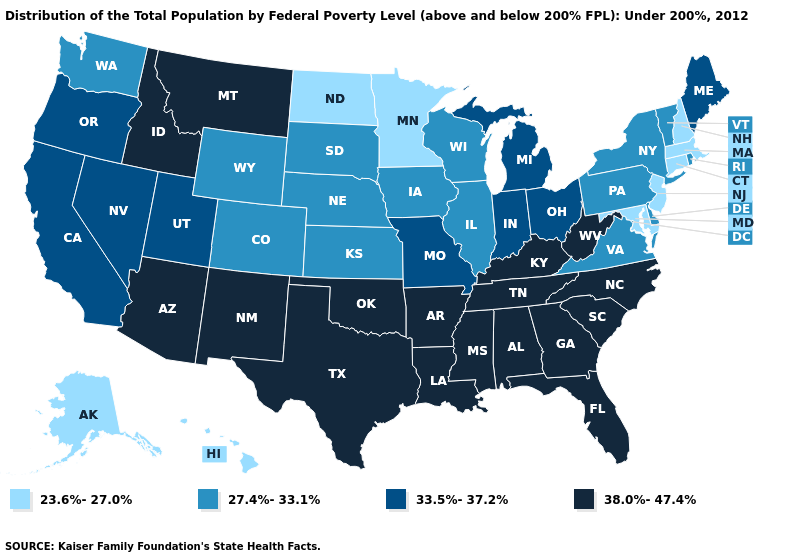Name the states that have a value in the range 33.5%-37.2%?
Write a very short answer. California, Indiana, Maine, Michigan, Missouri, Nevada, Ohio, Oregon, Utah. Does New Mexico have the highest value in the West?
Quick response, please. Yes. What is the value of Maine?
Short answer required. 33.5%-37.2%. What is the highest value in the Northeast ?
Quick response, please. 33.5%-37.2%. Name the states that have a value in the range 38.0%-47.4%?
Quick response, please. Alabama, Arizona, Arkansas, Florida, Georgia, Idaho, Kentucky, Louisiana, Mississippi, Montana, New Mexico, North Carolina, Oklahoma, South Carolina, Tennessee, Texas, West Virginia. Name the states that have a value in the range 38.0%-47.4%?
Concise answer only. Alabama, Arizona, Arkansas, Florida, Georgia, Idaho, Kentucky, Louisiana, Mississippi, Montana, New Mexico, North Carolina, Oklahoma, South Carolina, Tennessee, Texas, West Virginia. Name the states that have a value in the range 23.6%-27.0%?
Quick response, please. Alaska, Connecticut, Hawaii, Maryland, Massachusetts, Minnesota, New Hampshire, New Jersey, North Dakota. Among the states that border Utah , which have the highest value?
Concise answer only. Arizona, Idaho, New Mexico. Does Wisconsin have the lowest value in the USA?
Write a very short answer. No. What is the value of Michigan?
Keep it brief. 33.5%-37.2%. Does Kentucky have the highest value in the South?
Short answer required. Yes. Which states have the lowest value in the USA?
Give a very brief answer. Alaska, Connecticut, Hawaii, Maryland, Massachusetts, Minnesota, New Hampshire, New Jersey, North Dakota. What is the value of Indiana?
Write a very short answer. 33.5%-37.2%. Does Minnesota have the lowest value in the USA?
Be succinct. Yes. Which states have the lowest value in the Northeast?
Give a very brief answer. Connecticut, Massachusetts, New Hampshire, New Jersey. 